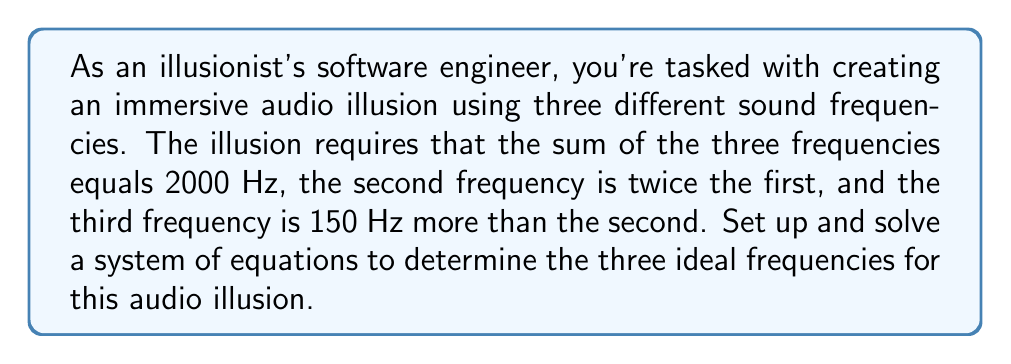Can you answer this question? Let's approach this step-by-step:

1) Define variables:
   Let $x$ = first frequency
   Let $y$ = second frequency
   Let $z$ = third frequency

2) Set up the system of equations based on the given conditions:
   
   $$\begin{cases}
   x + y + z = 2000 & \text{(sum of frequencies)}\\
   y = 2x & \text{(second is twice the first)}\\
   z = y + 150 & \text{(third is 150 Hz more than second)}
   \end{cases}$$

3) Substitute the second equation into the first and third:
   
   $$\begin{cases}
   x + 2x + z = 2000\\
   z = 2x + 150
   \end{cases}$$

4) Substitute the new second equation into the first:
   
   $x + 2x + (2x + 150) = 2000$

5) Simplify:
   
   $5x + 150 = 2000$

6) Solve for $x$:
   
   $5x = 1850$
   $x = 370$

7) Calculate $y$ and $z$:
   
   $y = 2x = 2(370) = 740$
   $z = y + 150 = 740 + 150 = 890$

8) Verify the solution:
   
   $370 + 740 + 890 = 2000$ (sum is correct)
   $740 = 2(370)$ (second is twice the first)
   $890 = 740 + 150$ (third is 150 Hz more than second)

Therefore, the three ideal frequencies are 370 Hz, 740 Hz, and 890 Hz.
Answer: The ideal frequencies for the audio illusion are:
First frequency: 370 Hz
Second frequency: 740 Hz
Third frequency: 890 Hz 